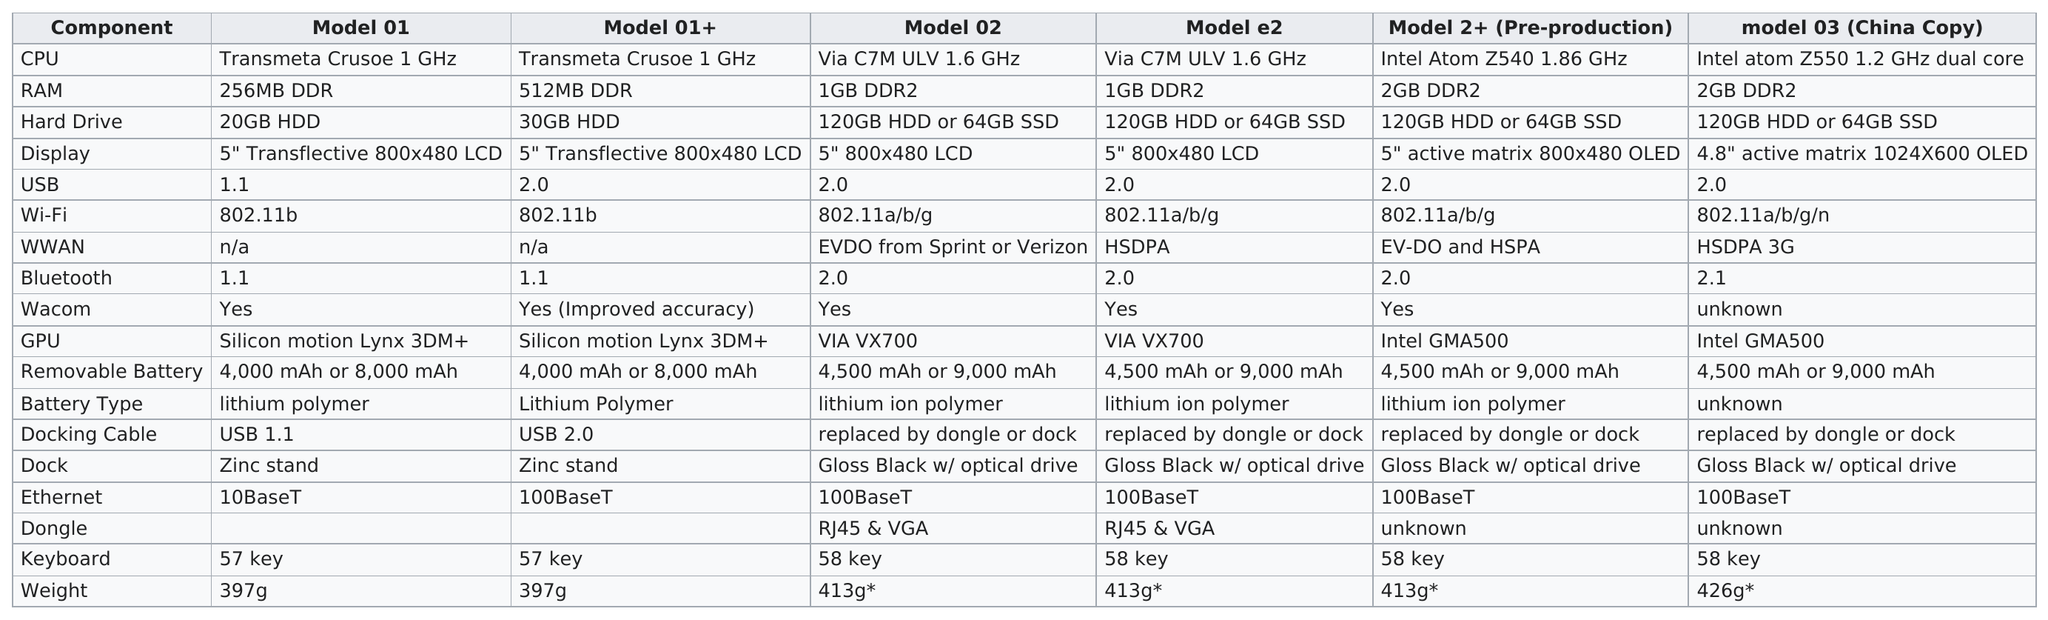Highlight a few significant elements in this photo. The next highest hard drive available after the 30GB model is the 64GB SSD. The total number of components on the chart is 18. The Model 3 has a greater weight than the Model 1, with a difference of 29 grams. According to the table provided, Model 03 (China Copy) appears to be the model that weighs the most. Out of the models that have a 1.6GHz processor, two of them meet the criteria you specified. 